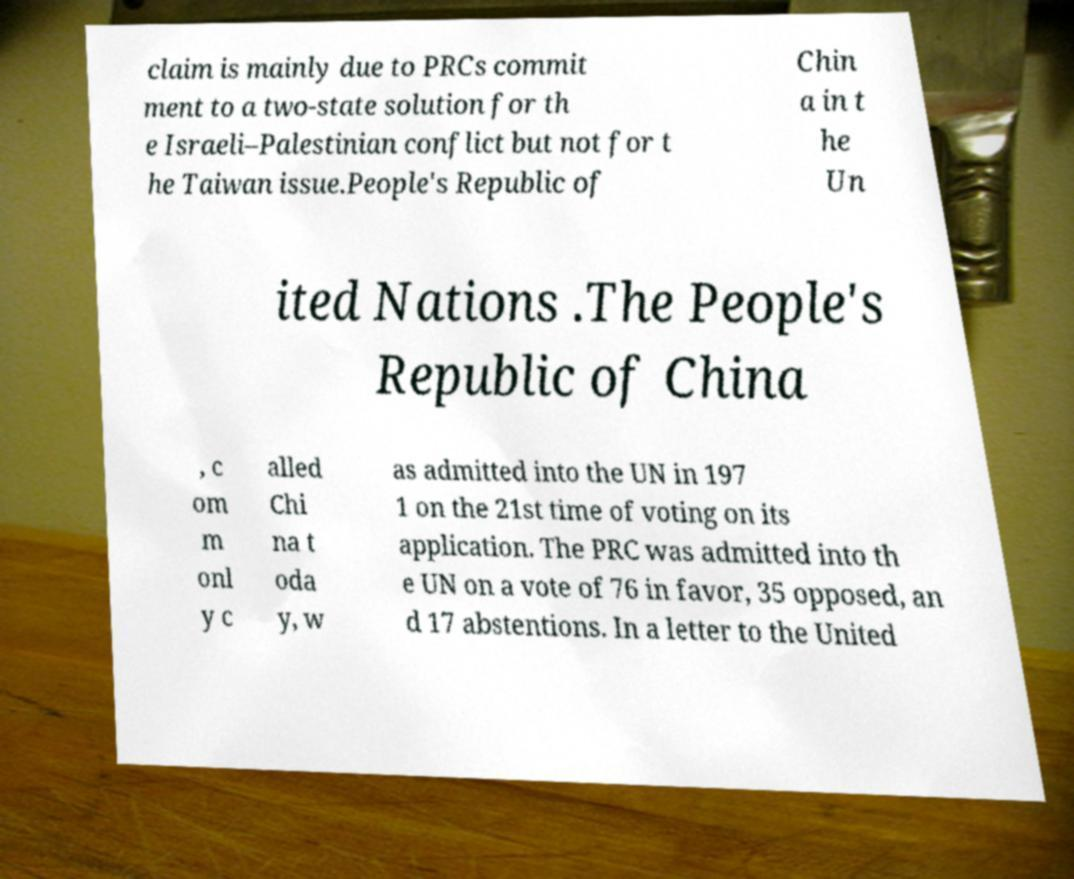Can you read and provide the text displayed in the image?This photo seems to have some interesting text. Can you extract and type it out for me? claim is mainly due to PRCs commit ment to a two-state solution for th e Israeli–Palestinian conflict but not for t he Taiwan issue.People's Republic of Chin a in t he Un ited Nations .The People's Republic of China , c om m onl y c alled Chi na t oda y, w as admitted into the UN in 197 1 on the 21st time of voting on its application. The PRC was admitted into th e UN on a vote of 76 in favor, 35 opposed, an d 17 abstentions. In a letter to the United 